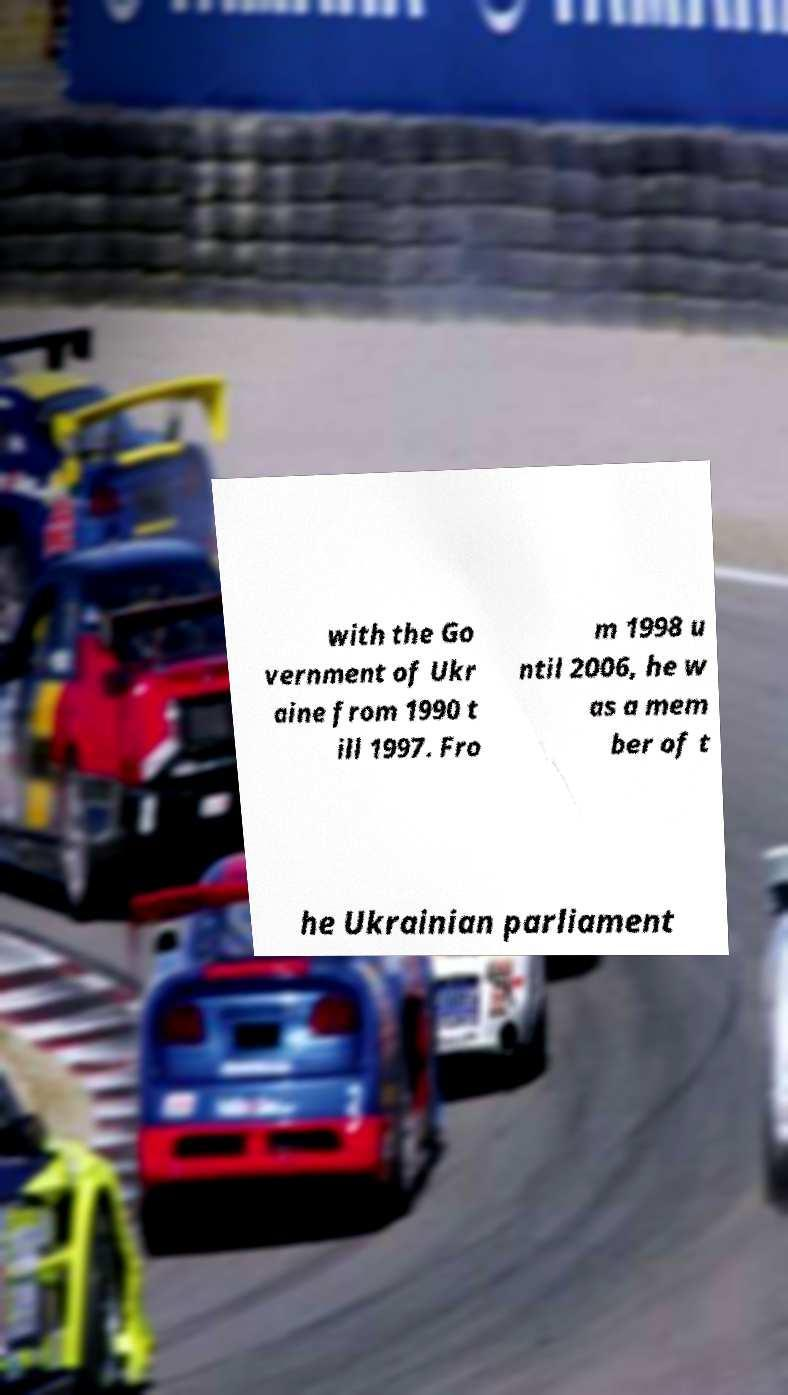Please identify and transcribe the text found in this image. with the Go vernment of Ukr aine from 1990 t ill 1997. Fro m 1998 u ntil 2006, he w as a mem ber of t he Ukrainian parliament 